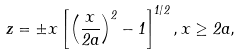<formula> <loc_0><loc_0><loc_500><loc_500>z = \pm x \left [ \left ( \frac { x } { 2 a } \right ) ^ { 2 } - 1 \right ] ^ { 1 / 2 } , x \geq 2 a ,</formula> 